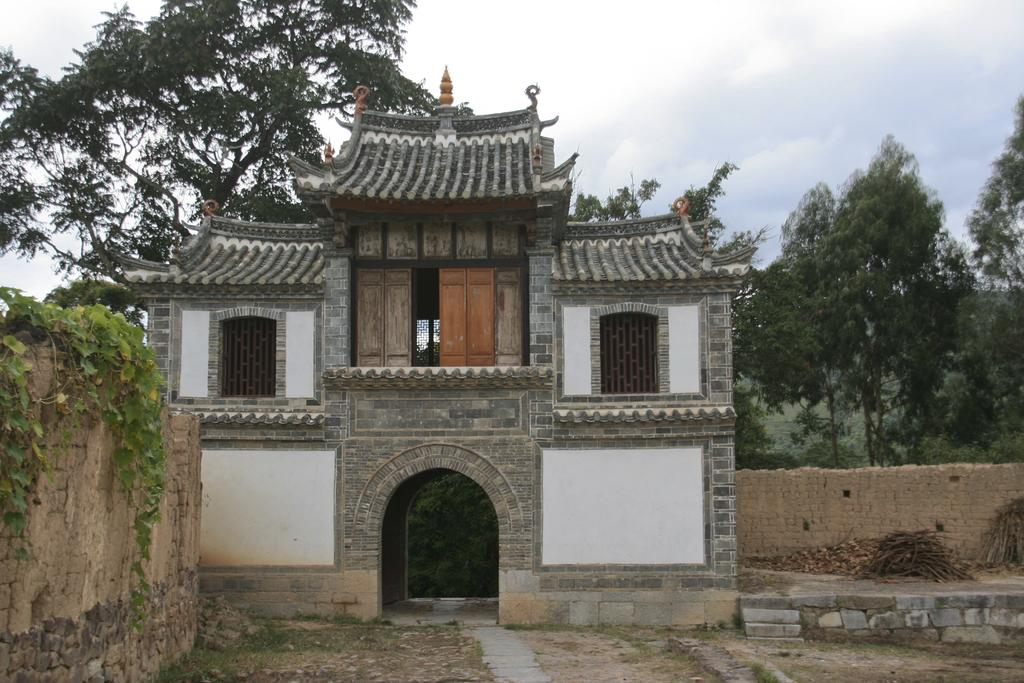What type of structure is in the image? There is a building in the image. What features can be seen on the building? The building has windows and doors. What type of vegetation is present in the image? There are trees in the image. What is growing on the walls of the building? Creepers are present on the walls of the building. What is located on the ground in the image? There is a pile of wooden sticks in the image. What can be seen above the building in the image? The sky is visible in the image, and clouds are present in the sky. What type of thought can be seen in the image? There are no thoughts visible in the image; it is a picture of a building, trees, and other physical objects. How many eggs are present in the image? There are no eggs present in the image. 